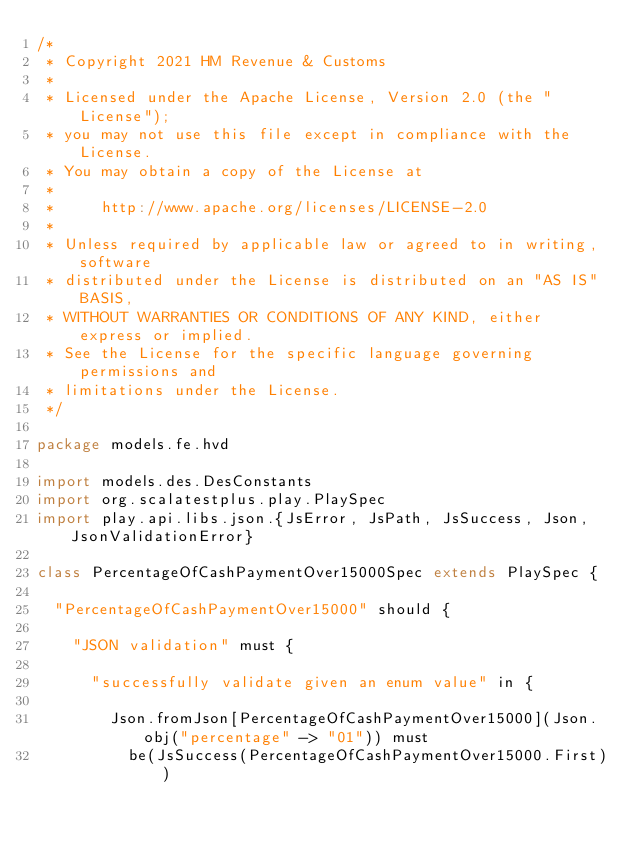Convert code to text. <code><loc_0><loc_0><loc_500><loc_500><_Scala_>/*
 * Copyright 2021 HM Revenue & Customs
 *
 * Licensed under the Apache License, Version 2.0 (the "License");
 * you may not use this file except in compliance with the License.
 * You may obtain a copy of the License at
 *
 *     http://www.apache.org/licenses/LICENSE-2.0
 *
 * Unless required by applicable law or agreed to in writing, software
 * distributed under the License is distributed on an "AS IS" BASIS,
 * WITHOUT WARRANTIES OR CONDITIONS OF ANY KIND, either express or implied.
 * See the License for the specific language governing permissions and
 * limitations under the License.
 */

package models.fe.hvd

import models.des.DesConstants
import org.scalatestplus.play.PlaySpec
import play.api.libs.json.{JsError, JsPath, JsSuccess, Json, JsonValidationError}

class PercentageOfCashPaymentOver15000Spec extends PlaySpec {

  "PercentageOfCashPaymentOver15000" should {

    "JSON validation" must {

      "successfully validate given an enum value" in {

        Json.fromJson[PercentageOfCashPaymentOver15000](Json.obj("percentage" -> "01")) must
          be(JsSuccess(PercentageOfCashPaymentOver15000.First))
</code> 